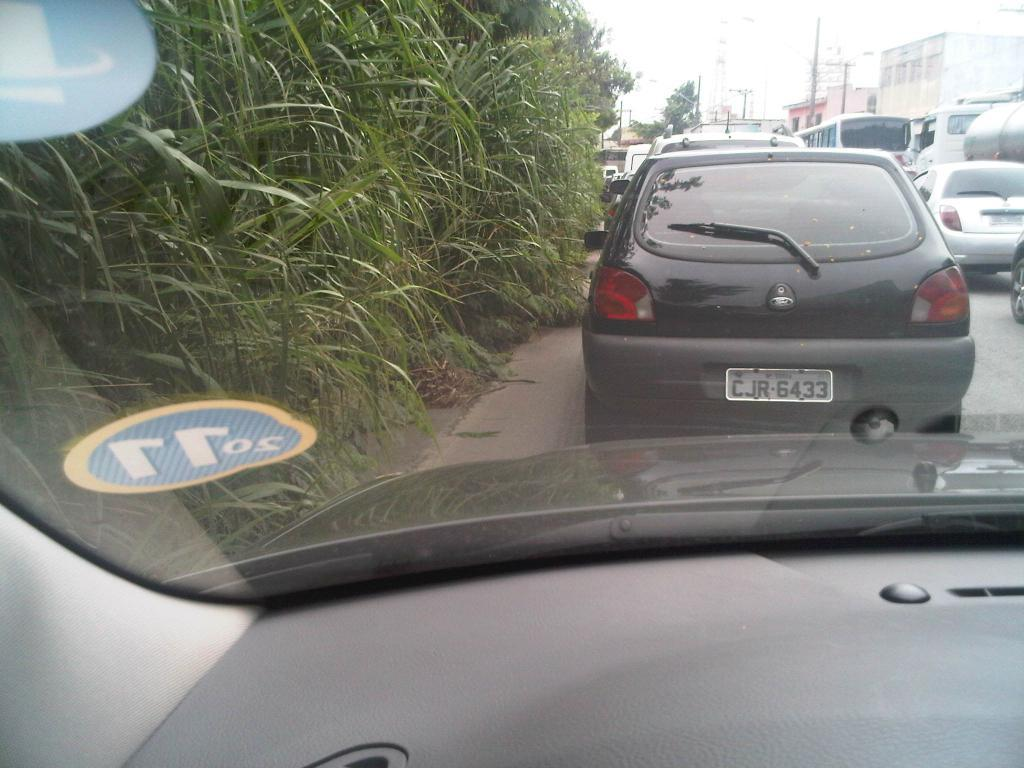<image>
Describe the image concisely. Car with a white license plate which says CJR6433 on it. 